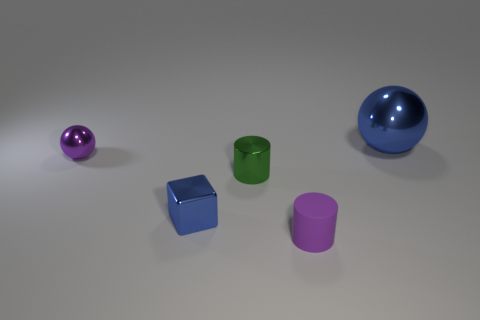Is there anything else that has the same size as the blue shiny sphere?
Keep it short and to the point. No. How many things are tiny purple cylinders or matte spheres?
Provide a succinct answer. 1. There is a blue sphere; is its size the same as the purple thing to the left of the rubber cylinder?
Your response must be concise. No. There is a blue shiny object that is on the left side of the blue shiny thing on the right side of the small cylinder in front of the cube; what is its size?
Offer a very short reply. Small. Are there any yellow cylinders?
Ensure brevity in your answer.  No. There is another thing that is the same color as the tiny matte thing; what is it made of?
Ensure brevity in your answer.  Metal. What number of cylinders have the same color as the small metallic sphere?
Ensure brevity in your answer.  1. What number of things are either things behind the metal cylinder or shiny objects in front of the big thing?
Offer a terse response. 4. There is a metal ball that is to the left of the blue shiny ball; how many tiny cylinders are behind it?
Give a very brief answer. 0. There is a big object that is made of the same material as the small cube; what color is it?
Provide a short and direct response. Blue. 